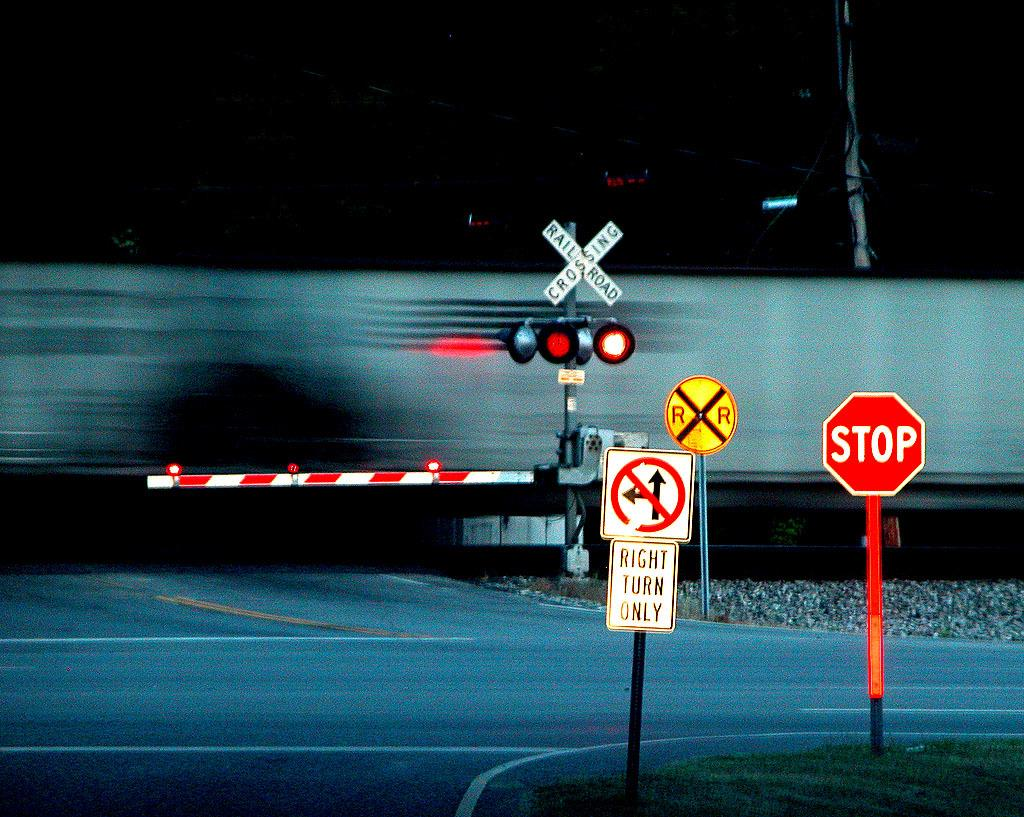<image>
Present a compact description of the photo's key features. The white sign explains that cars can turn right only. 